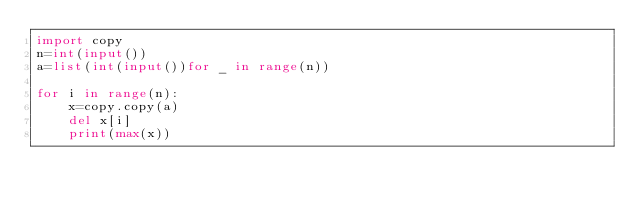Convert code to text. <code><loc_0><loc_0><loc_500><loc_500><_Python_>import copy
n=int(input())
a=list(int(input())for _ in range(n))

for i in range(n):
    x=copy.copy(a)
    del x[i]
    print(max(x))
    </code> 